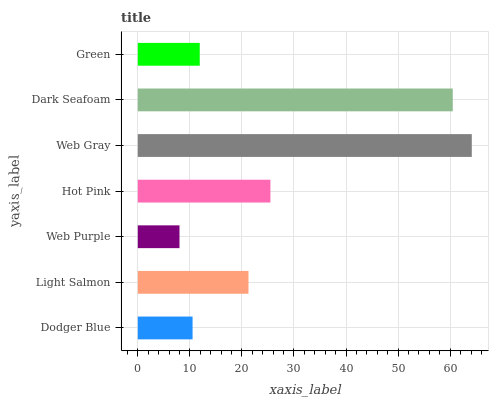Is Web Purple the minimum?
Answer yes or no. Yes. Is Web Gray the maximum?
Answer yes or no. Yes. Is Light Salmon the minimum?
Answer yes or no. No. Is Light Salmon the maximum?
Answer yes or no. No. Is Light Salmon greater than Dodger Blue?
Answer yes or no. Yes. Is Dodger Blue less than Light Salmon?
Answer yes or no. Yes. Is Dodger Blue greater than Light Salmon?
Answer yes or no. No. Is Light Salmon less than Dodger Blue?
Answer yes or no. No. Is Light Salmon the high median?
Answer yes or no. Yes. Is Light Salmon the low median?
Answer yes or no. Yes. Is Dark Seafoam the high median?
Answer yes or no. No. Is Web Purple the low median?
Answer yes or no. No. 